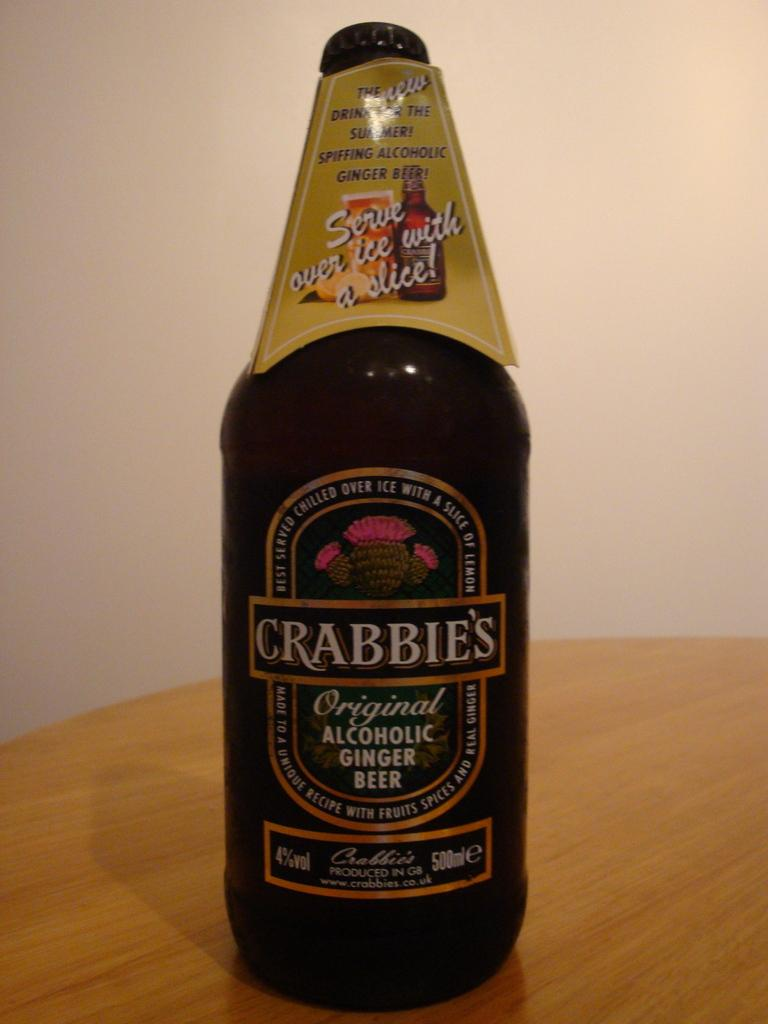<image>
Summarize the visual content of the image. "CRABBIE'S" is on the label of a ginger beer. 